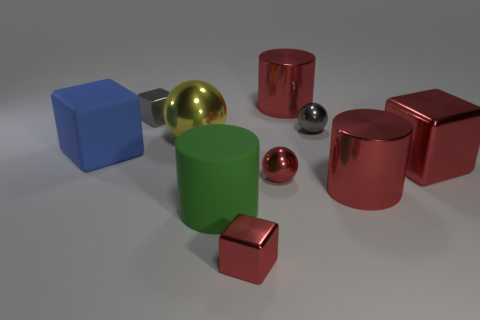Subtract 2 red blocks. How many objects are left? 8 Subtract all blocks. How many objects are left? 6 Subtract 2 spheres. How many spheres are left? 1 Subtract all cyan cubes. Subtract all blue cylinders. How many cubes are left? 4 Subtract all brown cylinders. How many red balls are left? 1 Subtract all tiny gray metal spheres. Subtract all cyan rubber balls. How many objects are left? 9 Add 8 matte objects. How many matte objects are left? 10 Add 7 green things. How many green things exist? 8 Subtract all red cylinders. How many cylinders are left? 1 Subtract all tiny spheres. How many spheres are left? 1 